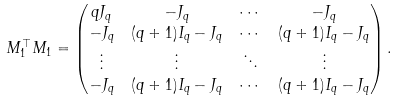Convert formula to latex. <formula><loc_0><loc_0><loc_500><loc_500>M _ { 1 } ^ { \top } M _ { 1 } & = \begin{pmatrix} q J _ { q } & - J _ { q } & \cdots & - J _ { q } \\ - J _ { q } & ( q + 1 ) I _ { q } - J _ { q } & \cdots & ( q + 1 ) I _ { q } - J _ { q } \\ \vdots & \vdots & \ddots & \vdots \\ - J _ { q } & ( q + 1 ) I _ { q } - J _ { q } & \cdots & ( q + 1 ) I _ { q } - J _ { q } \end{pmatrix} .</formula> 